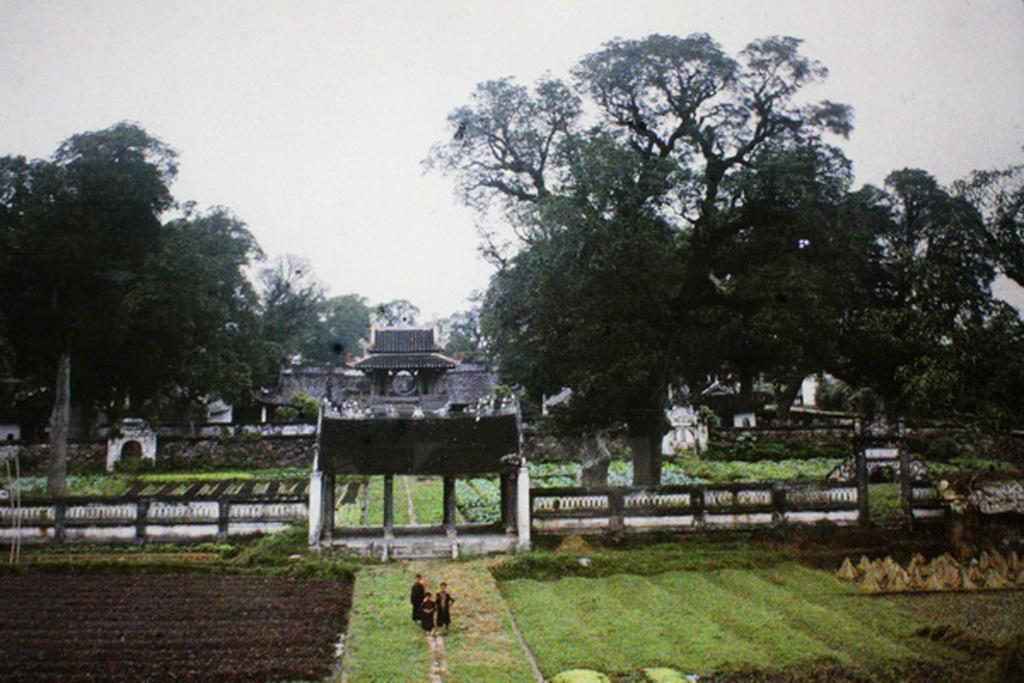Can you describe this image briefly? In this image in the center there are persons standing and there's grass on the ground. In the background there are trees and there is a building in the center. On the left side there is an arch and on the right side there are plants and there is an arch. 